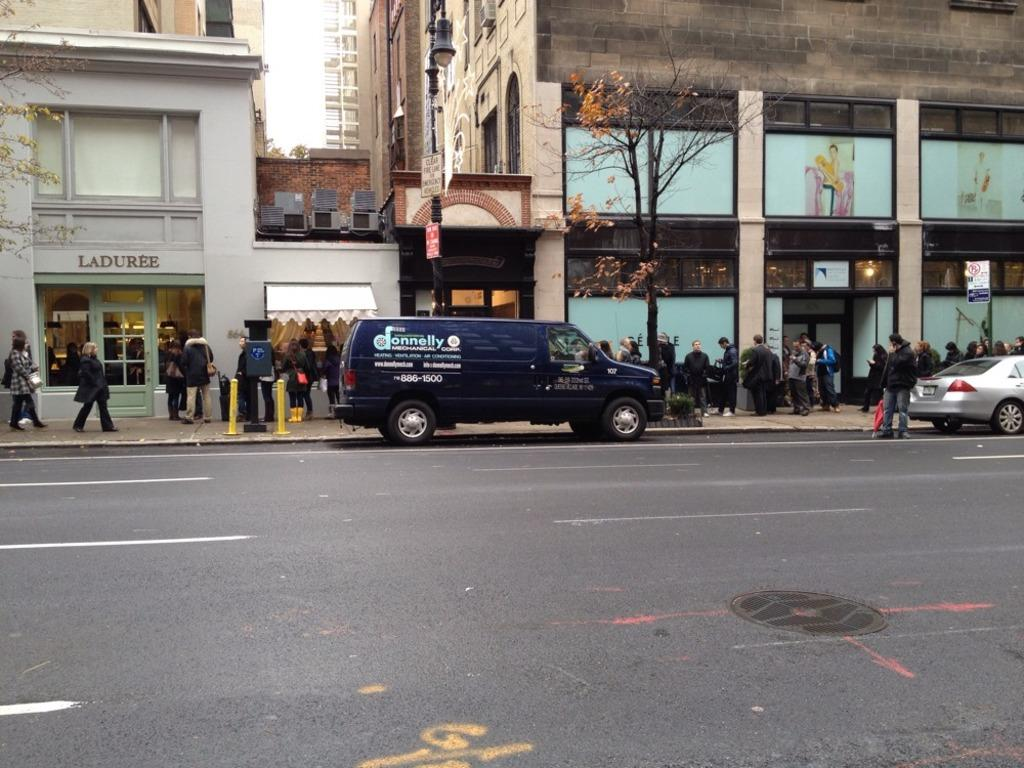<image>
Summarize the visual content of the image. Dark van which says the word DONNELLY on it. 